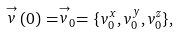Convert formula to latex. <formula><loc_0><loc_0><loc_500><loc_500>\stackrel { \rightarrow } { v } ( 0 ) = \stackrel { \rightarrow } { v } _ { 0 } = \{ v _ { 0 } ^ { x } , v _ { 0 } ^ { y } , v _ { 0 } ^ { z } \} ,</formula> 